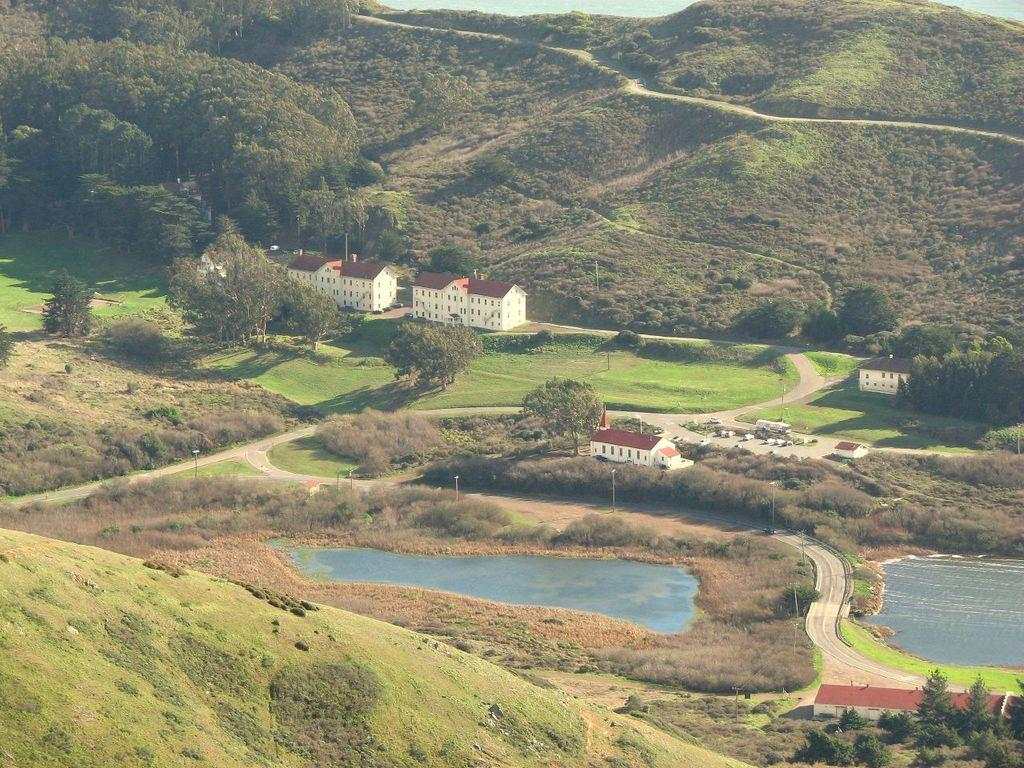What type of vegetation can be seen in the image? There are trees in the image. What type of structures are present in the image? There are houses in the image. What natural feature can be seen in the image? There is water visible in the image, specifically lakes. What type of surface is present in the image? There is a road in the image. What type of ground cover is visible in the image? There is grass in the image. What type of geographical feature can be seen in the image? There are hills in the image. What type of basket is being used for dinner in the image? There is no basket or dinner present in the image; it features trees, houses, water, lakes, a road, grass, and hills. 